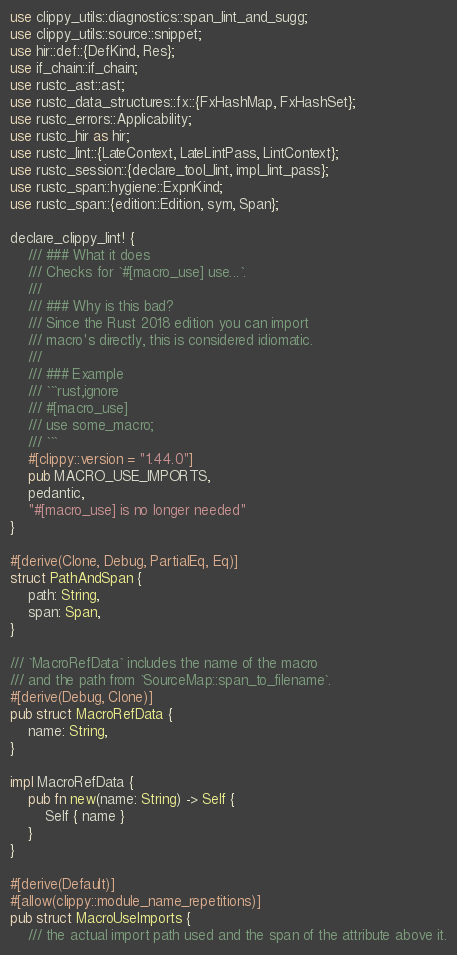Convert code to text. <code><loc_0><loc_0><loc_500><loc_500><_Rust_>use clippy_utils::diagnostics::span_lint_and_sugg;
use clippy_utils::source::snippet;
use hir::def::{DefKind, Res};
use if_chain::if_chain;
use rustc_ast::ast;
use rustc_data_structures::fx::{FxHashMap, FxHashSet};
use rustc_errors::Applicability;
use rustc_hir as hir;
use rustc_lint::{LateContext, LateLintPass, LintContext};
use rustc_session::{declare_tool_lint, impl_lint_pass};
use rustc_span::hygiene::ExpnKind;
use rustc_span::{edition::Edition, sym, Span};

declare_clippy_lint! {
    /// ### What it does
    /// Checks for `#[macro_use] use...`.
    ///
    /// ### Why is this bad?
    /// Since the Rust 2018 edition you can import
    /// macro's directly, this is considered idiomatic.
    ///
    /// ### Example
    /// ```rust,ignore
    /// #[macro_use]
    /// use some_macro;
    /// ```
    #[clippy::version = "1.44.0"]
    pub MACRO_USE_IMPORTS,
    pedantic,
    "#[macro_use] is no longer needed"
}

#[derive(Clone, Debug, PartialEq, Eq)]
struct PathAndSpan {
    path: String,
    span: Span,
}

/// `MacroRefData` includes the name of the macro
/// and the path from `SourceMap::span_to_filename`.
#[derive(Debug, Clone)]
pub struct MacroRefData {
    name: String,
}

impl MacroRefData {
    pub fn new(name: String) -> Self {
        Self { name }
    }
}

#[derive(Default)]
#[allow(clippy::module_name_repetitions)]
pub struct MacroUseImports {
    /// the actual import path used and the span of the attribute above it.</code> 